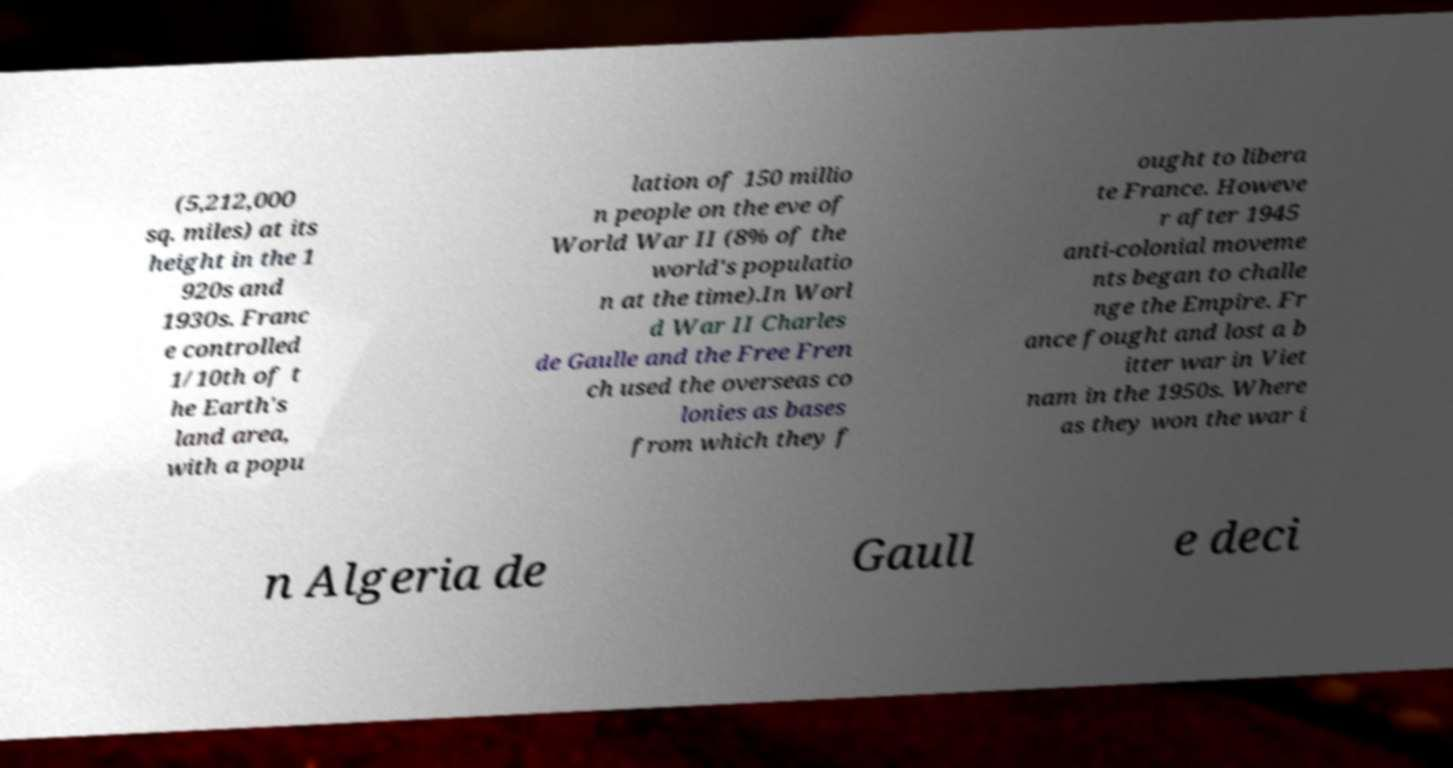For documentation purposes, I need the text within this image transcribed. Could you provide that? (5,212,000 sq. miles) at its height in the 1 920s and 1930s. Franc e controlled 1/10th of t he Earth's land area, with a popu lation of 150 millio n people on the eve of World War II (8% of the world's populatio n at the time).In Worl d War II Charles de Gaulle and the Free Fren ch used the overseas co lonies as bases from which they f ought to libera te France. Howeve r after 1945 anti-colonial moveme nts began to challe nge the Empire. Fr ance fought and lost a b itter war in Viet nam in the 1950s. Where as they won the war i n Algeria de Gaull e deci 